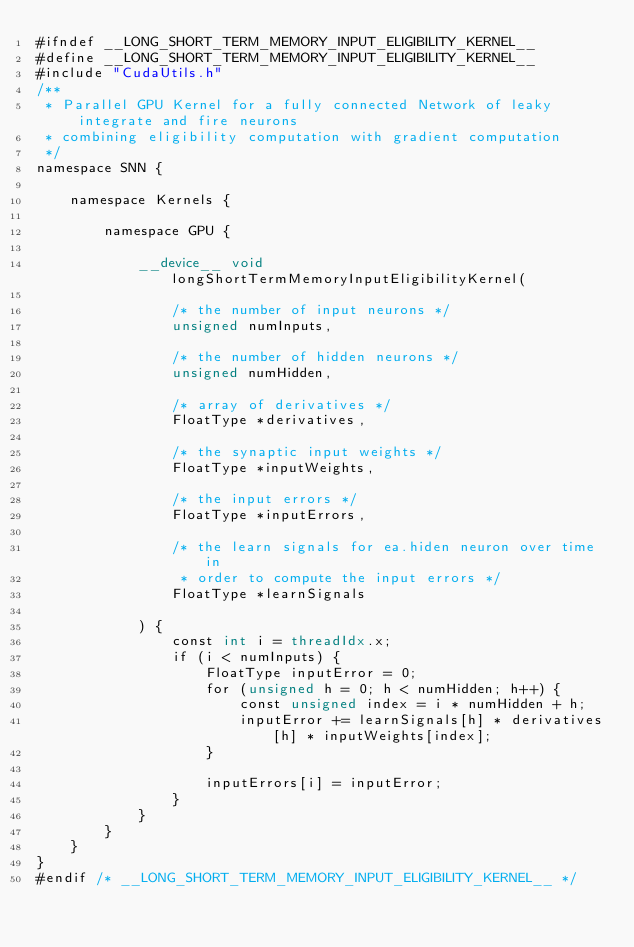<code> <loc_0><loc_0><loc_500><loc_500><_Cuda_>#ifndef __LONG_SHORT_TERM_MEMORY_INPUT_ELIGIBILITY_KERNEL__
#define __LONG_SHORT_TERM_MEMORY_INPUT_ELIGIBILITY_KERNEL__
#include "CudaUtils.h"
/**
 * Parallel GPU Kernel for a fully connected Network of leaky integrate and fire neurons
 * combining eligibility computation with gradient computation 
 */
namespace SNN {

    namespace Kernels {

        namespace GPU {

            __device__ void longShortTermMemoryInputEligibilityKernel(

                /* the number of input neurons */
                unsigned numInputs,

                /* the number of hidden neurons */
                unsigned numHidden,

                /* array of derivatives */
                FloatType *derivatives,

                /* the synaptic input weights */
                FloatType *inputWeights,

                /* the input errors */
                FloatType *inputErrors,

                /* the learn signals for ea.hiden neuron over time in 
                 * order to compute the input errors */ 
                FloatType *learnSignals

            ) {
                const int i = threadIdx.x;
                if (i < numInputs) {
                    FloatType inputError = 0;
                    for (unsigned h = 0; h < numHidden; h++) {
                        const unsigned index = i * numHidden + h;
                        inputError += learnSignals[h] * derivatives[h] * inputWeights[index];
                    }

                    inputErrors[i] = inputError;
                }
            }
        }
    }
}
#endif /* __LONG_SHORT_TERM_MEMORY_INPUT_ELIGIBILITY_KERNEL__ */
</code> 